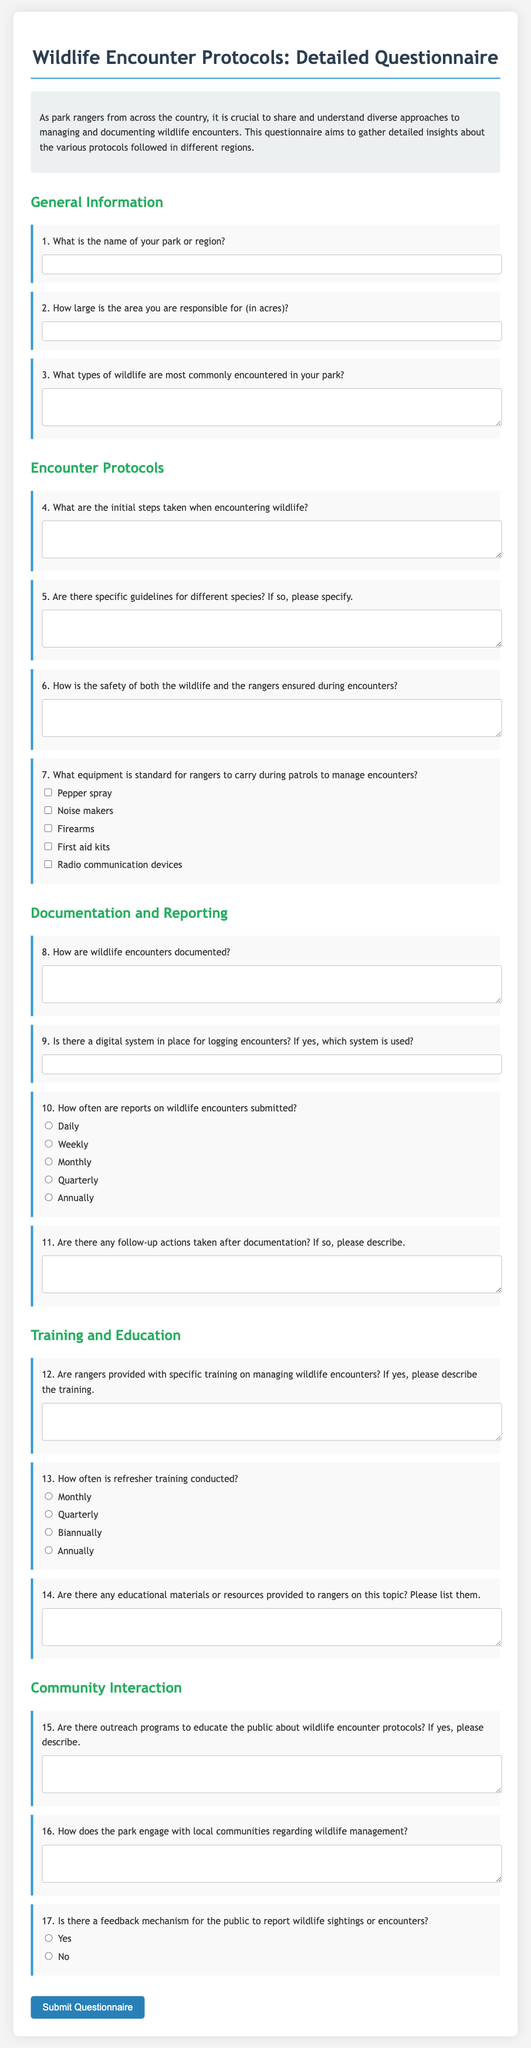What is the title of the questionnaire? The title can be found at the top of the document, indicating the topic covered.
Answer: Wildlife Encounter Protocols: Detailed Questionnaire How many questions are in the section on Encounter Protocols? The section on Encounter Protocols includes questions about initial steps, guidelines, safety, and equipment, which can be counted to find the total.
Answer: 4 What is the type of training mentioned for rangers? The question regarding ranger training specifies that there is specific training on managing wildlife encounters.
Answer: specific training What is the response format for question 10 about encounter report frequency? The question provides multiple choices for how often reports are submitted, indicating that it is a multiple-choice format.
Answer: Daily, Weekly, Monthly, Quarterly, Annually What equipment is listed as standard for rangers to carry during patrols? The document lists various equipment items in checkboxes that rangers might carry during patrols for managing encounters.
Answer: Pepper spray, Noise makers, Firearms, First aid kits, Radio communication devices What is the size requirement for the area responsible for managing wildlife? There is a specified field where park rangers must enter the size of the area.
Answer: in acres Are there specific guidelines for different species mentioned in the questionnaire? The questionnaire specifically asks if there are guidelines for different wildlife species, indicating a level of specificity in protocols.
Answer: Yes How often is refresher training conducted according to the options? The questionnaire provides options for the frequency of refresher training, indicating that this is a recurring aspect of ranger training.
Answer: Monthly, Quarterly, Biannually, Annually 